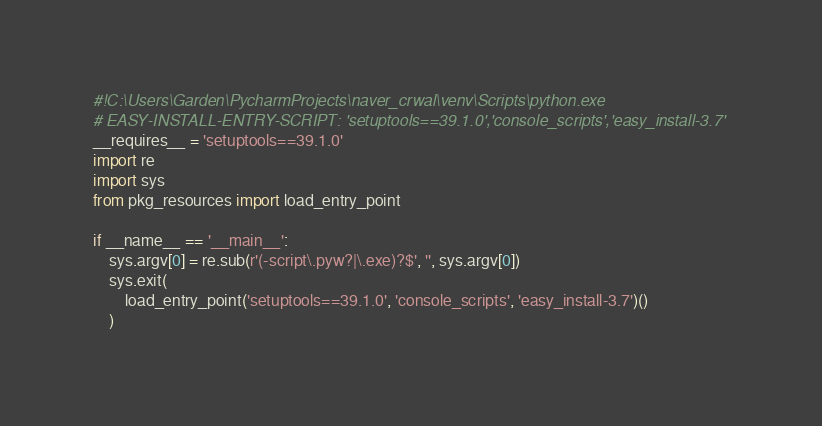Convert code to text. <code><loc_0><loc_0><loc_500><loc_500><_Python_>#!C:\Users\Garden\PycharmProjects\naver_crwal\venv\Scripts\python.exe
# EASY-INSTALL-ENTRY-SCRIPT: 'setuptools==39.1.0','console_scripts','easy_install-3.7'
__requires__ = 'setuptools==39.1.0'
import re
import sys
from pkg_resources import load_entry_point

if __name__ == '__main__':
    sys.argv[0] = re.sub(r'(-script\.pyw?|\.exe)?$', '', sys.argv[0])
    sys.exit(
        load_entry_point('setuptools==39.1.0', 'console_scripts', 'easy_install-3.7')()
    )
</code> 